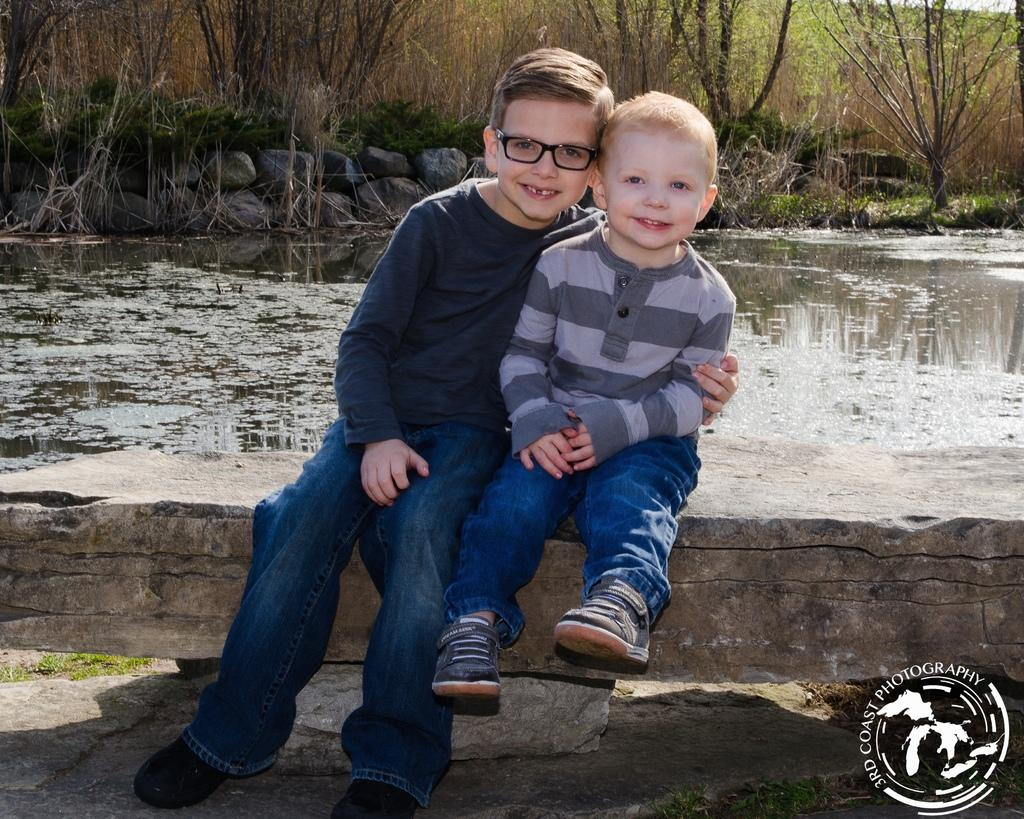How many boys are in the image? There are two boys in the image. What are the boys doing in the image? The boys are sitting in the image. What expression do the boys have in the image? The boys are smiling in the image. What is the primary element in the image? There is water in the image. What other objects can be seen in the image? There are rocks in the image. What is visible in the background of the image? There are trees in the background of the image. What year is depicted in the image? The image does not depict a specific year; it is a photograph of a scene with two boys sitting near water. What type of force is being applied by the boys in the image? There is no indication of any force being applied by the boys in the image; they are simply sitting and smiling. 